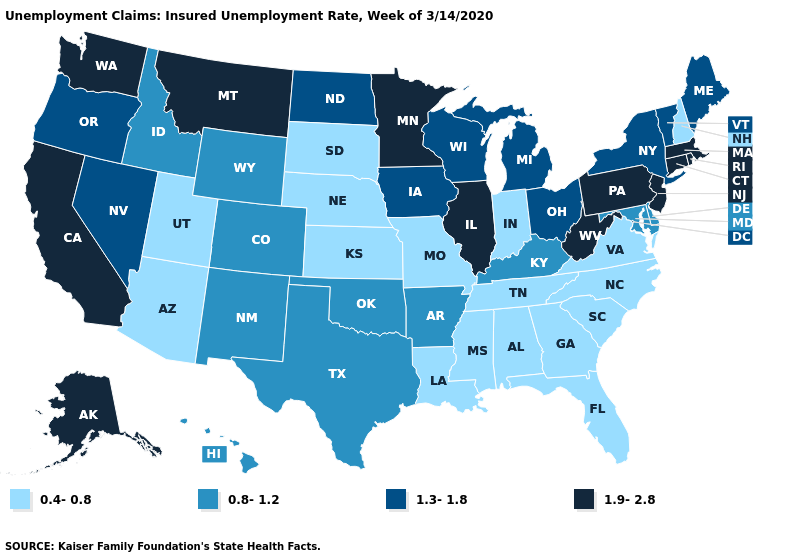Does Iowa have a higher value than Minnesota?
Be succinct. No. Name the states that have a value in the range 1.3-1.8?
Short answer required. Iowa, Maine, Michigan, Nevada, New York, North Dakota, Ohio, Oregon, Vermont, Wisconsin. What is the value of Michigan?
Keep it brief. 1.3-1.8. What is the value of Tennessee?
Short answer required. 0.4-0.8. What is the value of Tennessee?
Quick response, please. 0.4-0.8. Which states have the highest value in the USA?
Keep it brief. Alaska, California, Connecticut, Illinois, Massachusetts, Minnesota, Montana, New Jersey, Pennsylvania, Rhode Island, Washington, West Virginia. Does Alabama have the lowest value in the USA?
Short answer required. Yes. Name the states that have a value in the range 1.3-1.8?
Answer briefly. Iowa, Maine, Michigan, Nevada, New York, North Dakota, Ohio, Oregon, Vermont, Wisconsin. Name the states that have a value in the range 0.8-1.2?
Quick response, please. Arkansas, Colorado, Delaware, Hawaii, Idaho, Kentucky, Maryland, New Mexico, Oklahoma, Texas, Wyoming. How many symbols are there in the legend?
Be succinct. 4. What is the value of Maine?
Answer briefly. 1.3-1.8. What is the highest value in states that border Rhode Island?
Answer briefly. 1.9-2.8. Name the states that have a value in the range 1.9-2.8?
Short answer required. Alaska, California, Connecticut, Illinois, Massachusetts, Minnesota, Montana, New Jersey, Pennsylvania, Rhode Island, Washington, West Virginia. What is the value of Nebraska?
Answer briefly. 0.4-0.8. Does Louisiana have the same value as Georgia?
Be succinct. Yes. 